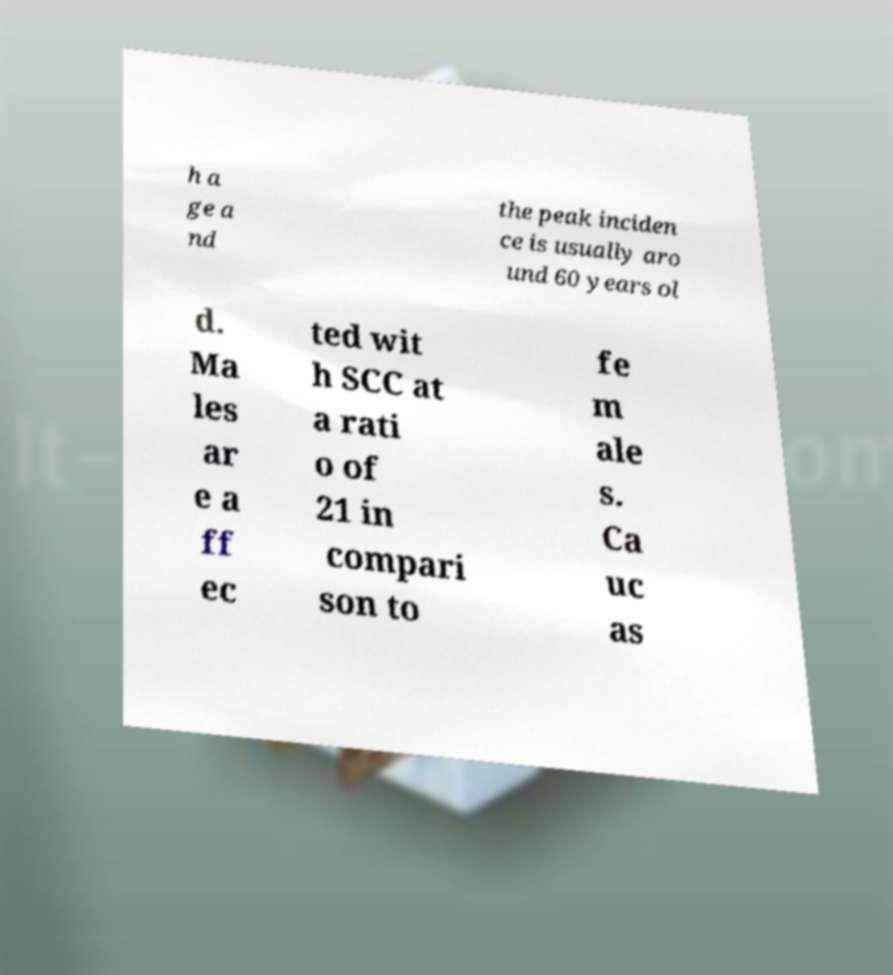Please identify and transcribe the text found in this image. h a ge a nd the peak inciden ce is usually aro und 60 years ol d. Ma les ar e a ff ec ted wit h SCC at a rati o of 21 in compari son to fe m ale s. Ca uc as 